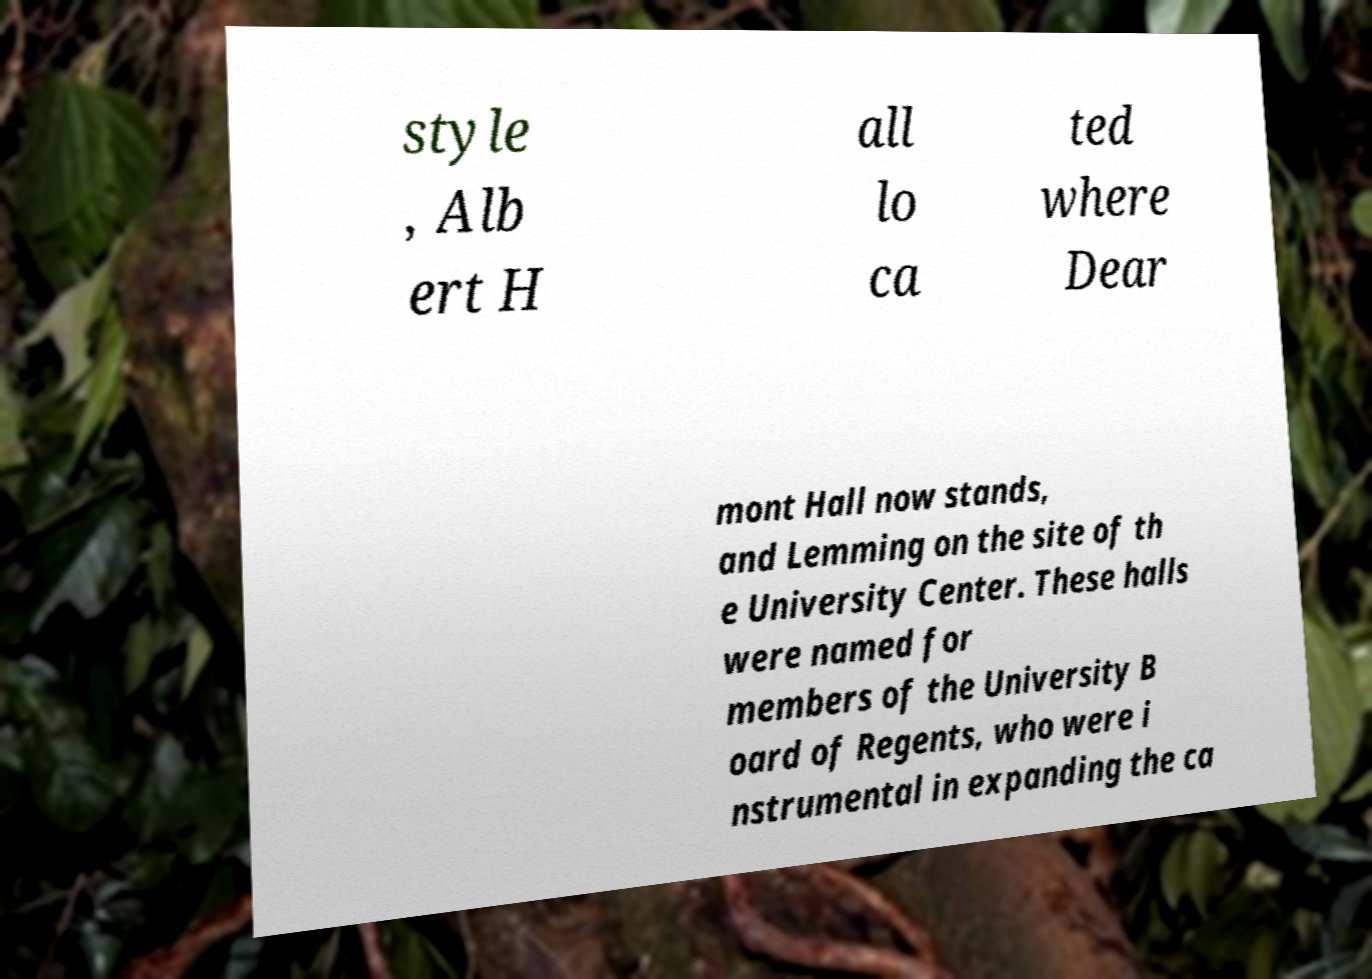There's text embedded in this image that I need extracted. Can you transcribe it verbatim? style , Alb ert H all lo ca ted where Dear mont Hall now stands, and Lemming on the site of th e University Center. These halls were named for members of the University B oard of Regents, who were i nstrumental in expanding the ca 